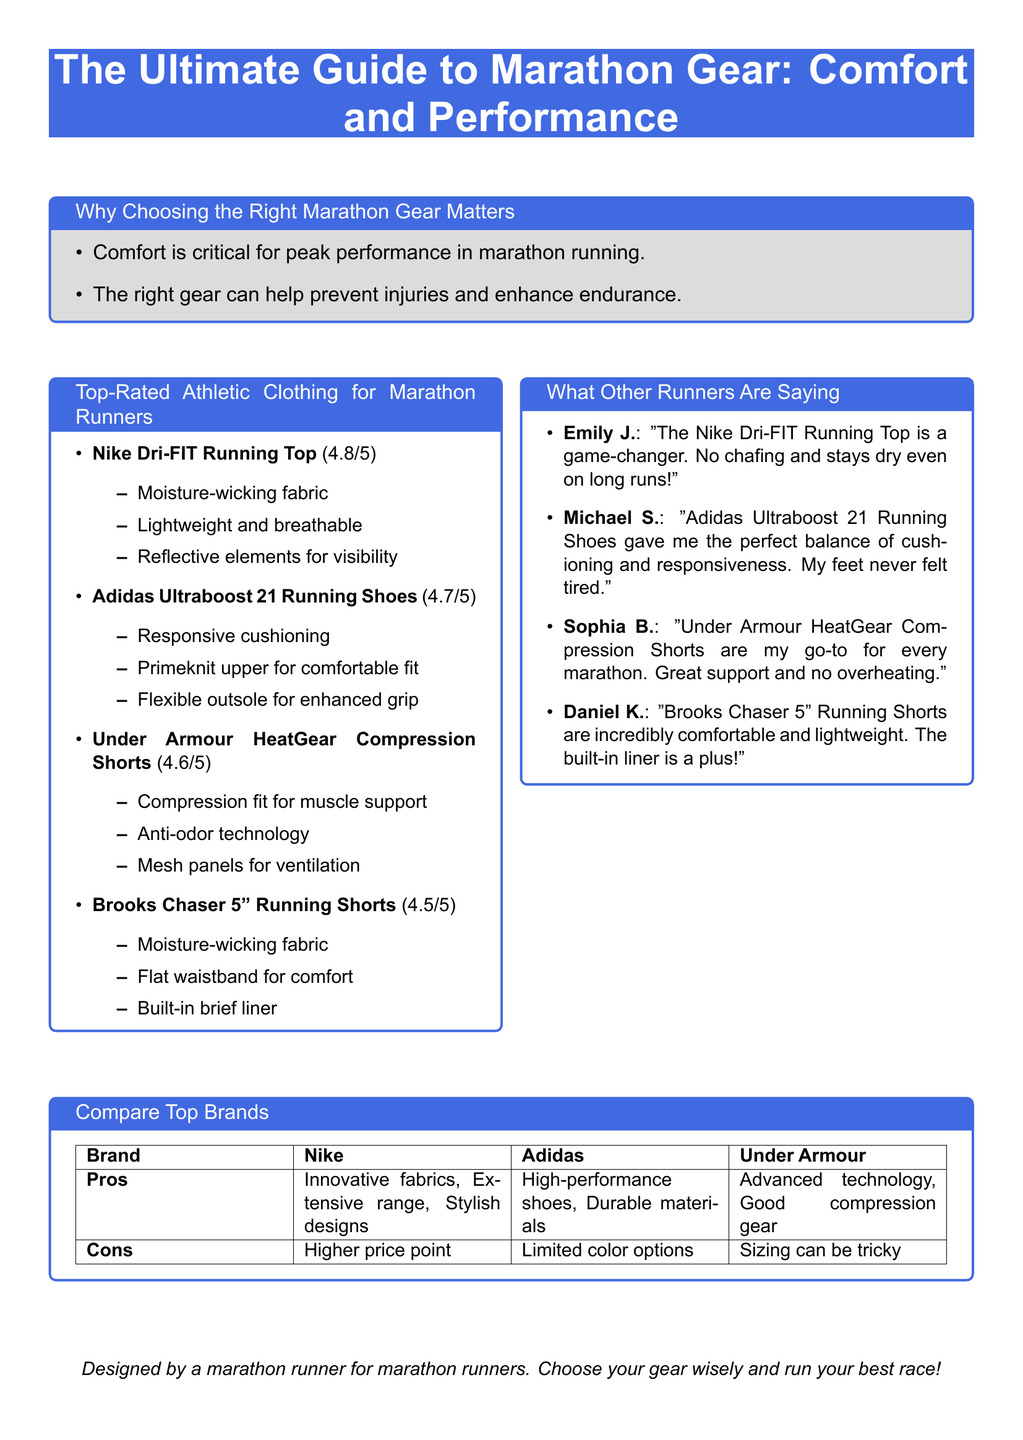what is the title of the document? The title is the main heading presented at the top of the flyer.
Answer: The Ultimate Guide to Marathon Gear: Comfort and Performance what is the rating of Adidas Ultraboost 21 Running Shoes? The rating is indicated next to the product name in the list of top-rated athletic clothing.
Answer: 4.7/5 what fabric does the Nike Dri-FIT Running Top use? The document describes the features of the Nike Dri-FIT Running Top under the product description.
Answer: Moisture-wicking fabric who is the user that praised the Under Armour HeatGear Compression Shorts? The testimonials include names of users who provided feedback on the listed products.
Answer: Sophia B what is one pro of the Nike brand? The pros of each brand are listed in the brand comparison table.
Answer: Innovative fabrics what is the only con listed for Under Armour? Each brand's cons are stated in the same table as the pros, providing a comparison.
Answer: Sizing can be tricky what is the purpose of the document? The document displays its purpose at the end of the content, emphasizing its design criteria.
Answer: Designed by a marathon runner for marathon runners how many top-rated athletic clothing items are listed? The list of top-rated athletic clothing items includes a specific number of items.
Answer: 4 